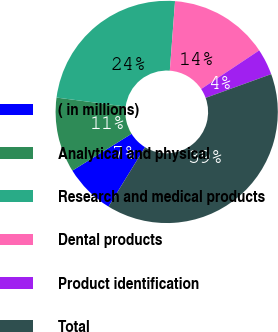Convert chart to OTSL. <chart><loc_0><loc_0><loc_500><loc_500><pie_chart><fcel>( in millions)<fcel>Analytical and physical<fcel>Research and medical products<fcel>Dental products<fcel>Product identification<fcel>Total<nl><fcel>7.37%<fcel>10.92%<fcel>24.13%<fcel>14.46%<fcel>3.82%<fcel>39.3%<nl></chart> 